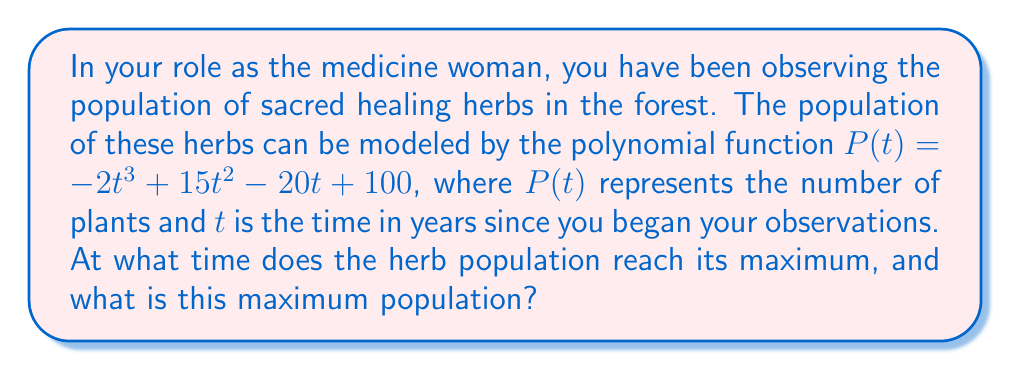Help me with this question. To find the maximum population, we need to find the vertex of the polynomial function. Since this is a cubic function, we'll use the derivative method:

1. Find the derivative of $P(t)$:
   $P'(t) = -6t^2 + 30t - 20$

2. Set the derivative equal to zero and solve for t:
   $-6t^2 + 30t - 20 = 0$
   
   This is a quadratic equation. We can solve it using the quadratic formula:
   $t = \frac{-b \pm \sqrt{b^2 - 4ac}}{2a}$

   Where $a = -6$, $b = 30$, and $c = -20$

   $t = \frac{-30 \pm \sqrt{30^2 - 4(-6)(-20)}}{2(-6)}$
   $t = \frac{-30 \pm \sqrt{900 - 480}}{-12}$
   $t = \frac{-30 \pm \sqrt{420}}{-12}$
   $t = \frac{-30 \pm 20.49}{-12}$

   This gives us two solutions:
   $t_1 = \frac{-30 + 20.49}{-12} \approx 0.79$ years
   $t_2 = \frac{-30 - 20.49}{-12} \approx 4.21$ years

3. The second derivative of $P(t)$ is:
   $P''(t) = -12t + 30$

   At $t = 0.79$, $P''(0.79) = -12(0.79) + 30 \approx 20.52 > 0$
   At $t = 4.21$, $P''(4.21) = -12(4.21) + 30 \approx -20.52 < 0$

   This confirms that the maximum occurs at $t \approx 4.21$ years.

4. To find the maximum population, we substitute $t = 4.21$ into the original function:

   $P(4.21) = -2(4.21)^3 + 15(4.21)^2 - 20(4.21) + 100$
   $\approx -2(74.62) + 15(17.72) - 20(4.21) + 100$
   $\approx -149.24 + 265.80 - 84.20 + 100$
   $\approx 132.36$

Therefore, the maximum population occurs after approximately 4.21 years and reaches about 132 plants.
Answer: The herb population reaches its maximum of approximately 132 plants after 4.21 years. 